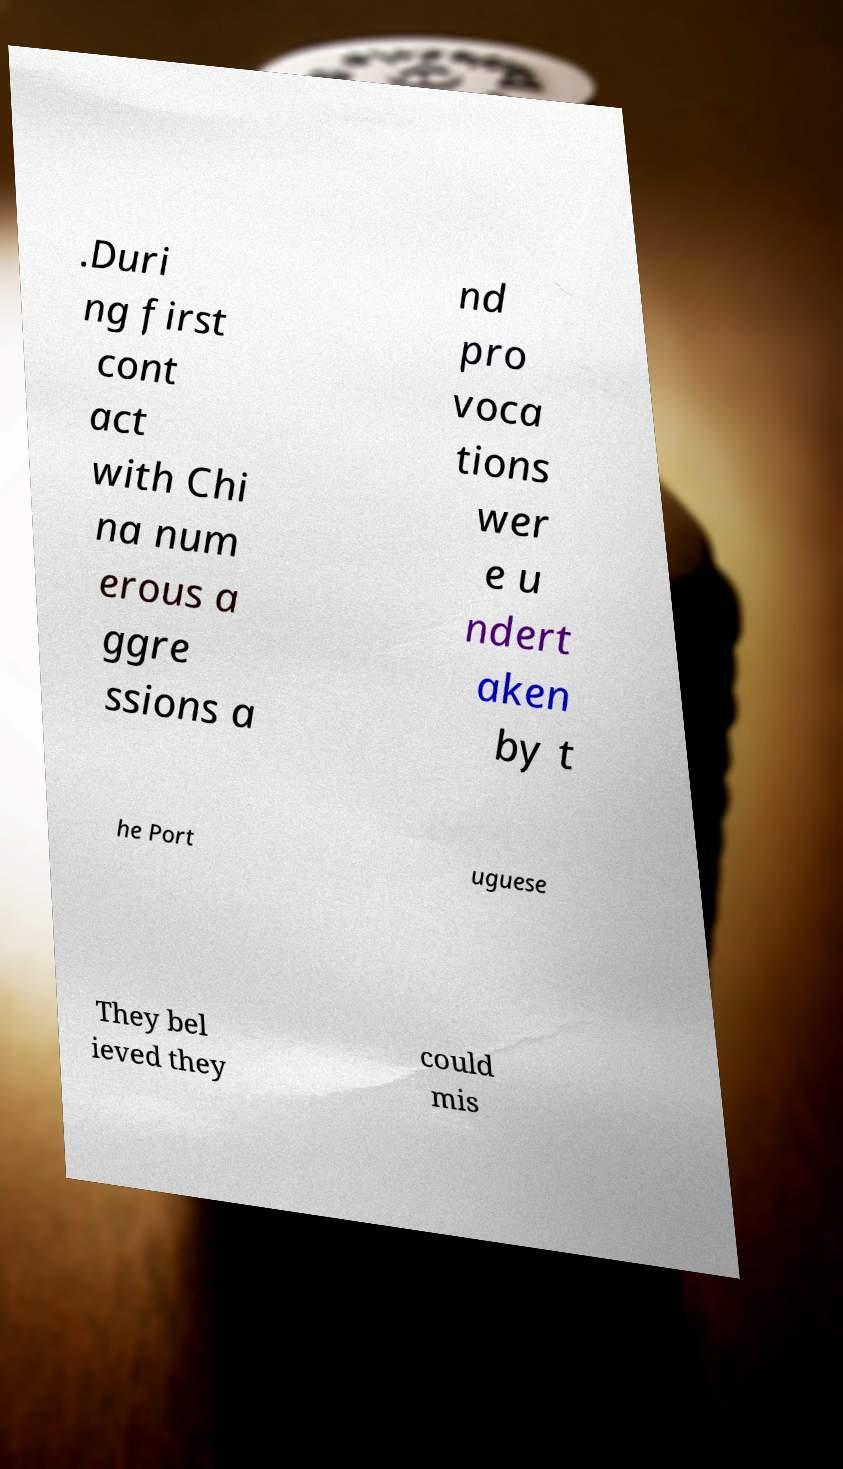I need the written content from this picture converted into text. Can you do that? .Duri ng first cont act with Chi na num erous a ggre ssions a nd pro voca tions wer e u ndert aken by t he Port uguese They bel ieved they could mis 